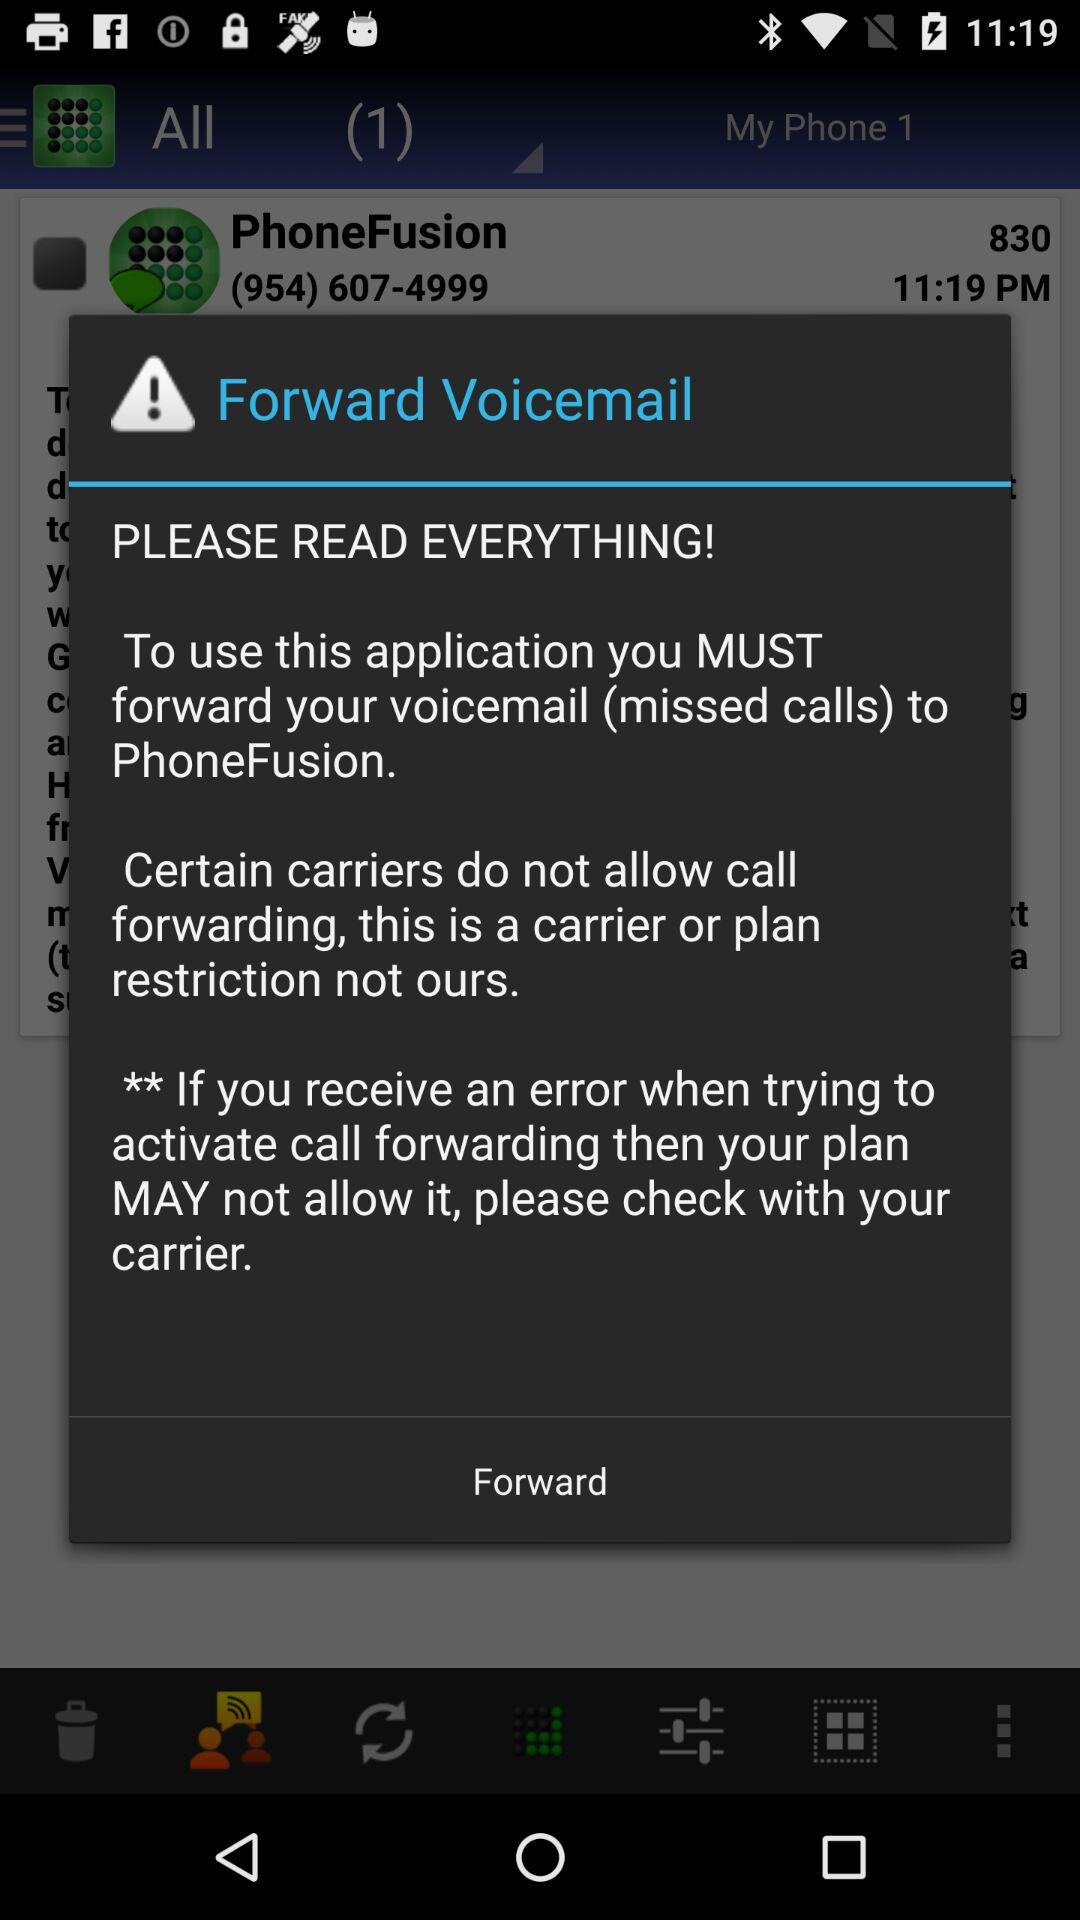What is the phone number of "PhoneFusion"? The phone number is (954) 607-4999. 